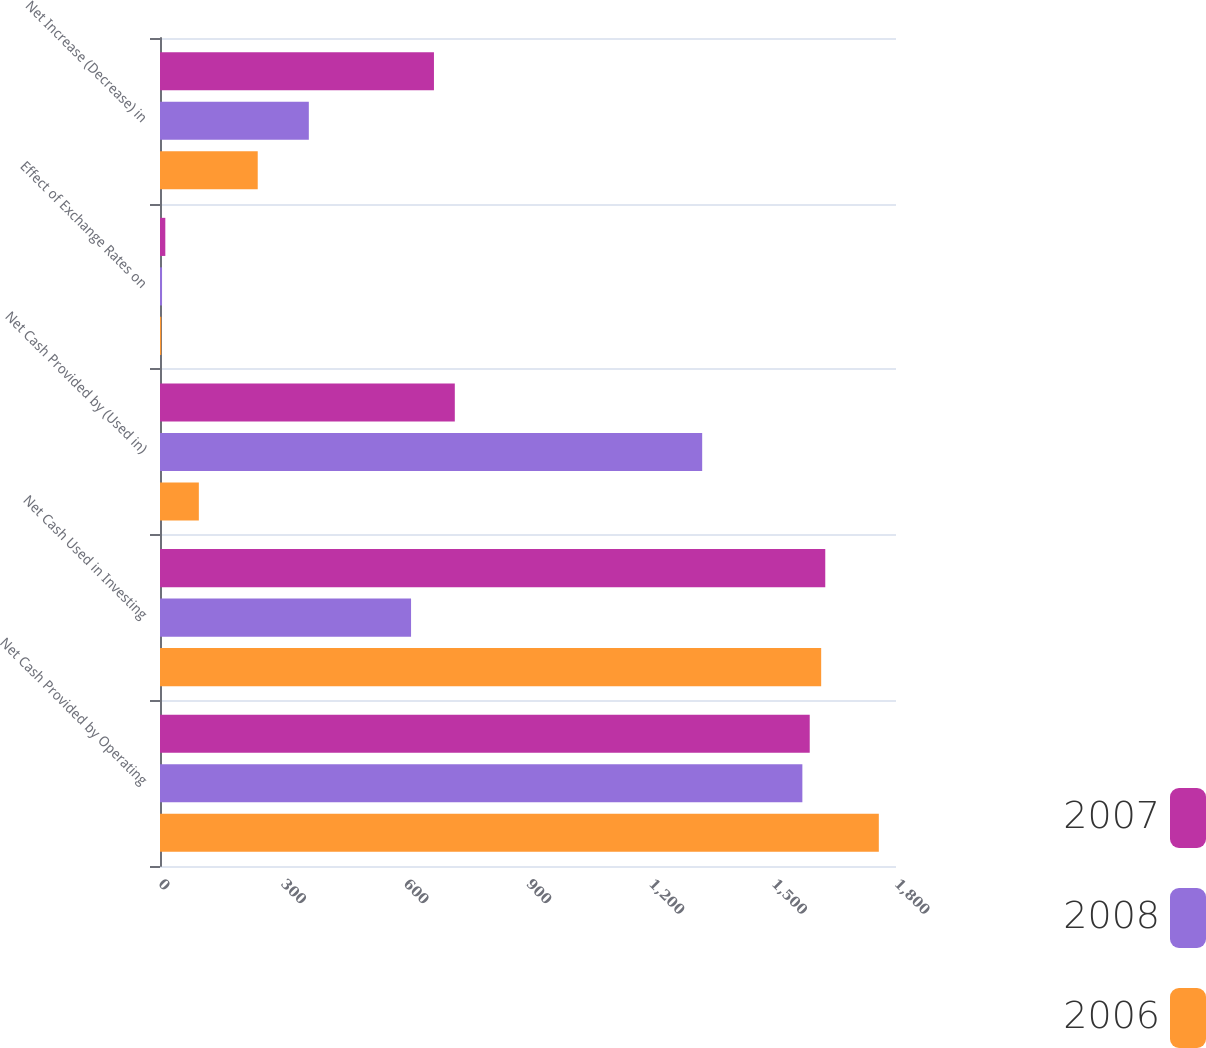Convert chart to OTSL. <chart><loc_0><loc_0><loc_500><loc_500><stacked_bar_chart><ecel><fcel>Net Cash Provided by Operating<fcel>Net Cash Used in Investing<fcel>Net Cash Provided by (Used in)<fcel>Effect of Exchange Rates on<fcel>Net Increase (Decrease) in<nl><fcel>2007<fcel>1589<fcel>1627<fcel>721<fcel>13<fcel>670<nl><fcel>2008<fcel>1571<fcel>614<fcel>1326<fcel>5<fcel>364<nl><fcel>2006<fcel>1758<fcel>1617<fcel>95<fcel>3<fcel>239<nl></chart> 